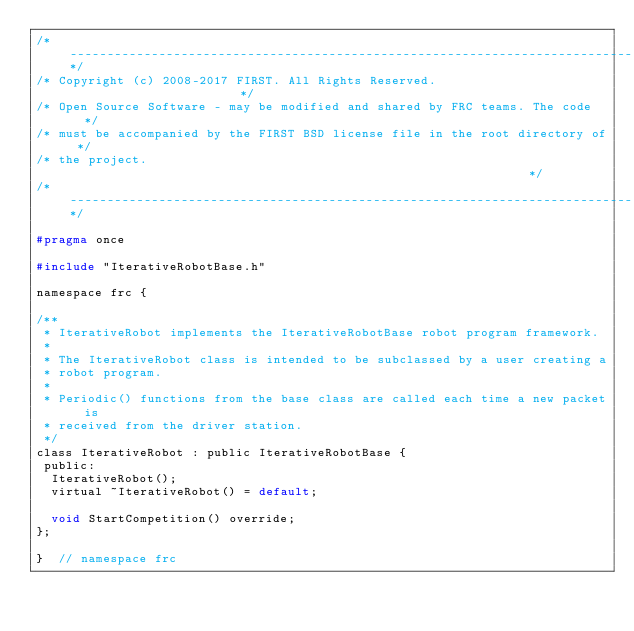<code> <loc_0><loc_0><loc_500><loc_500><_C_>/*----------------------------------------------------------------------------*/
/* Copyright (c) 2008-2017 FIRST. All Rights Reserved.                        */
/* Open Source Software - may be modified and shared by FRC teams. The code   */
/* must be accompanied by the FIRST BSD license file in the root directory of */
/* the project.                                                               */
/*----------------------------------------------------------------------------*/

#pragma once

#include "IterativeRobotBase.h"

namespace frc {

/**
 * IterativeRobot implements the IterativeRobotBase robot program framework.
 *
 * The IterativeRobot class is intended to be subclassed by a user creating a
 * robot program.
 *
 * Periodic() functions from the base class are called each time a new packet is
 * received from the driver station.
 */
class IterativeRobot : public IterativeRobotBase {
 public:
  IterativeRobot();
  virtual ~IterativeRobot() = default;

  void StartCompetition() override;
};

}  // namespace frc
</code> 